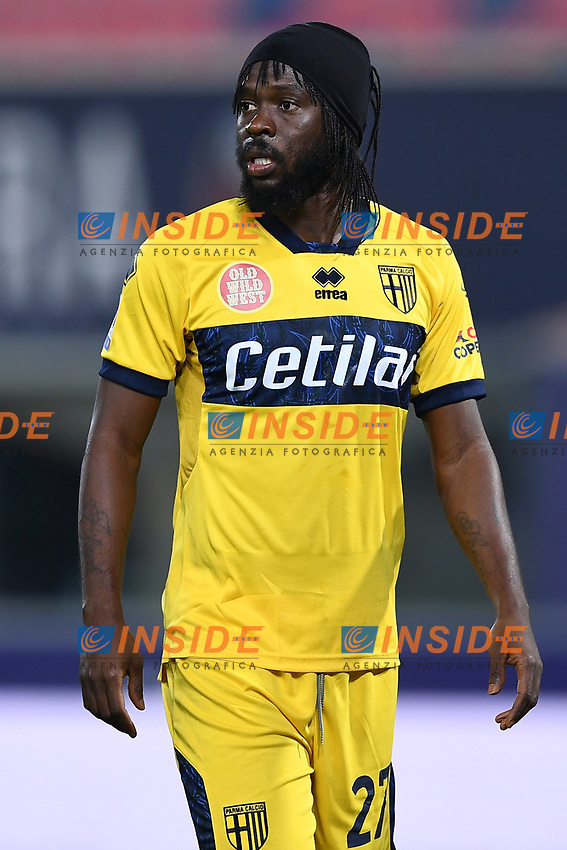Why might the player be wearing a headband? The headband worn by the player serves several functional purposes. Primarily, it helps to keep sweat from dripping into the eyes during the game, which can impair vision and performance. Additionally, it helps to keep hair managed, preventing it from obstructing vision during play. The headband can also be a stylistic choice, expressing personal style or team solidarity. 